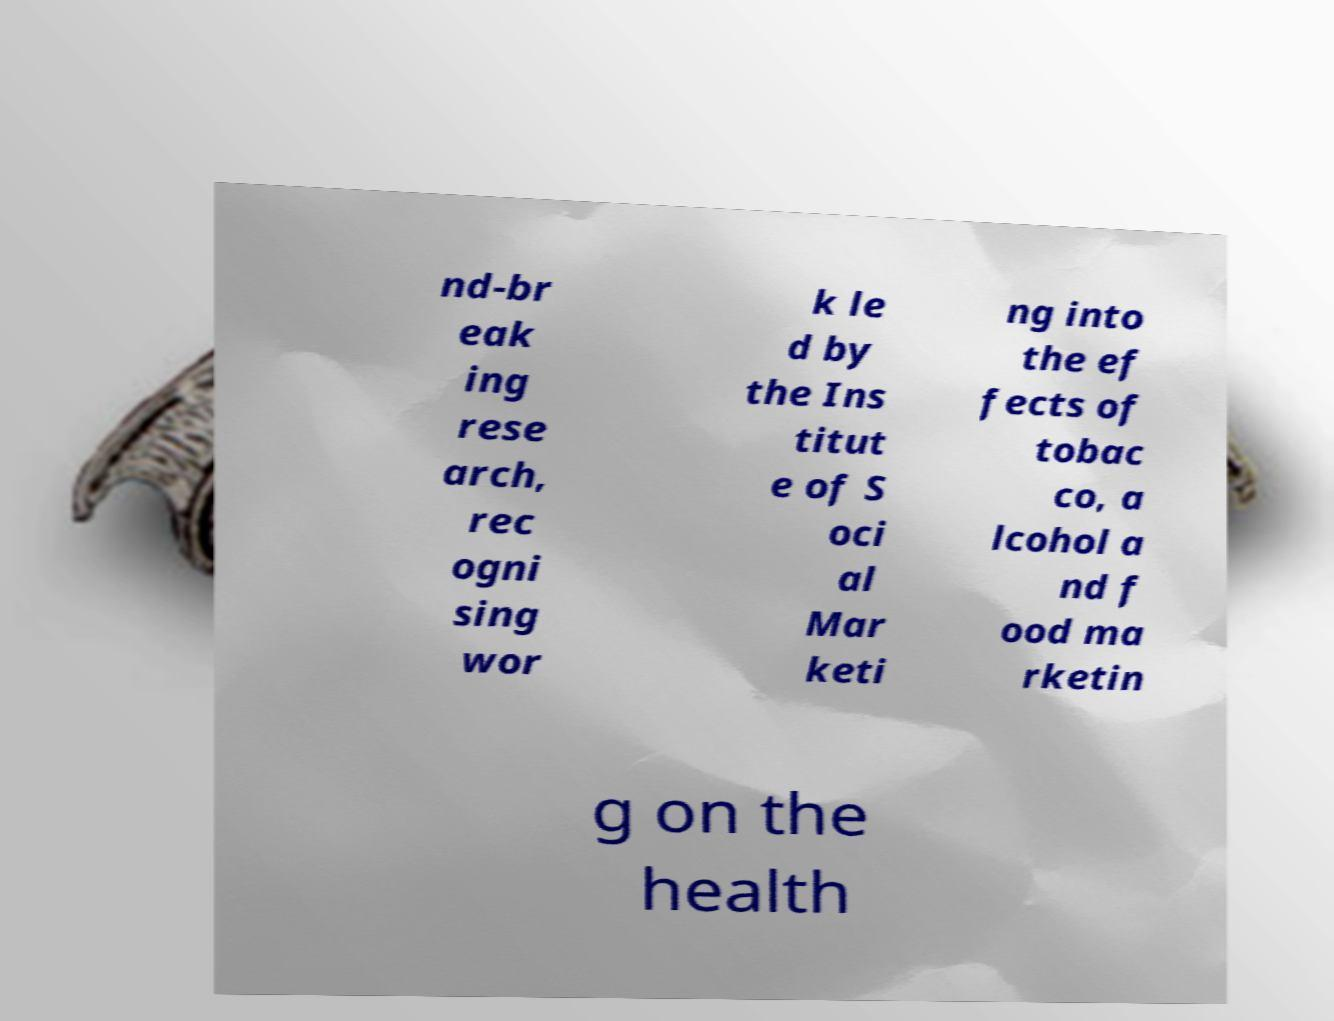Can you read and provide the text displayed in the image?This photo seems to have some interesting text. Can you extract and type it out for me? nd-br eak ing rese arch, rec ogni sing wor k le d by the Ins titut e of S oci al Mar keti ng into the ef fects of tobac co, a lcohol a nd f ood ma rketin g on the health 